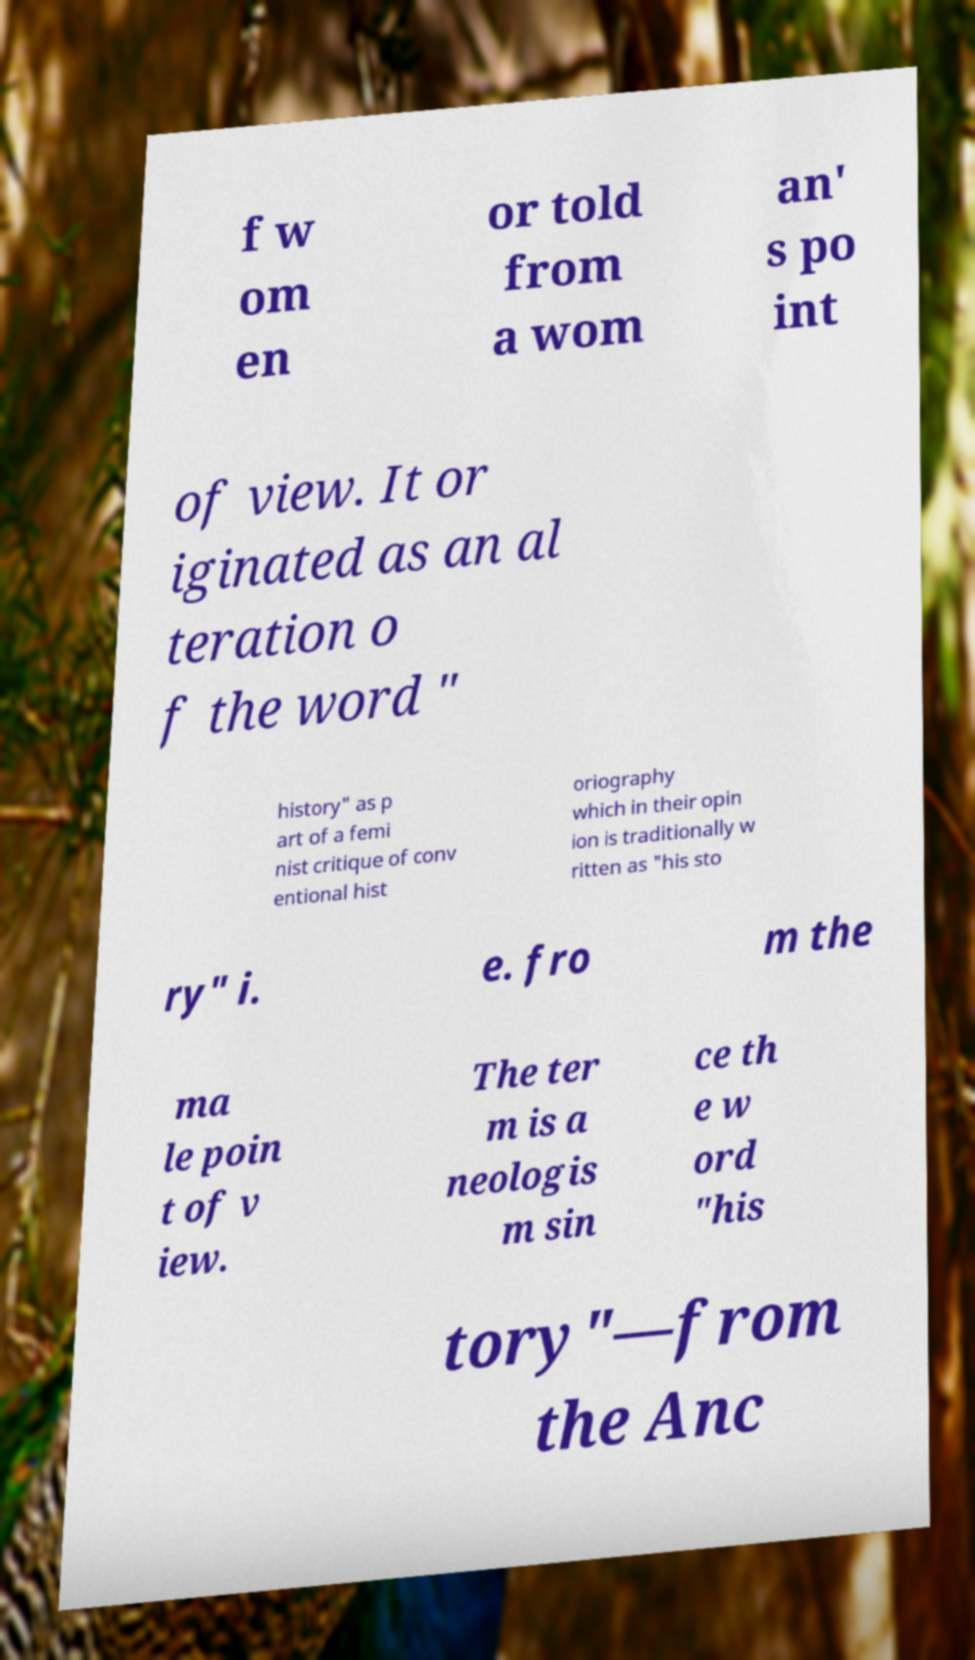Can you accurately transcribe the text from the provided image for me? f w om en or told from a wom an' s po int of view. It or iginated as an al teration o f the word " history" as p art of a femi nist critique of conv entional hist oriography which in their opin ion is traditionally w ritten as "his sto ry" i. e. fro m the ma le poin t of v iew. The ter m is a neologis m sin ce th e w ord "his tory"—from the Anc 